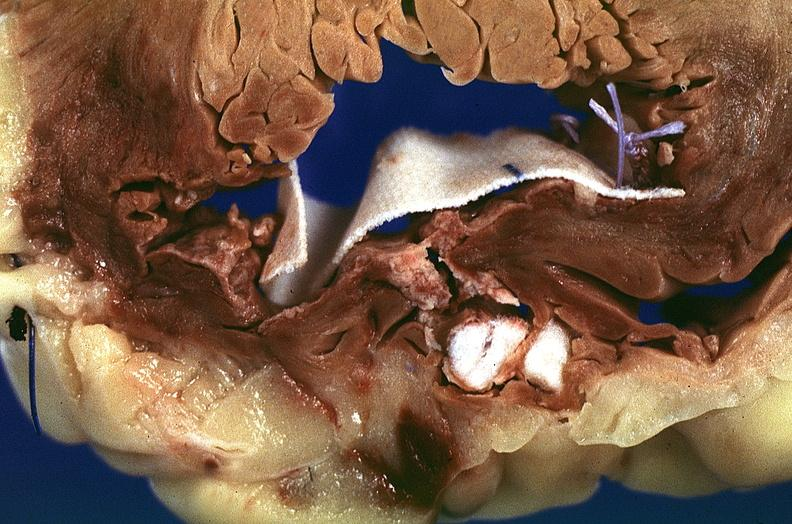what is present?
Answer the question using a single word or phrase. Cardiovascular 